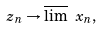Convert formula to latex. <formula><loc_0><loc_0><loc_500><loc_500>z _ { n } \rightarrow \overline { \lim } \ x _ { n } ,</formula> 